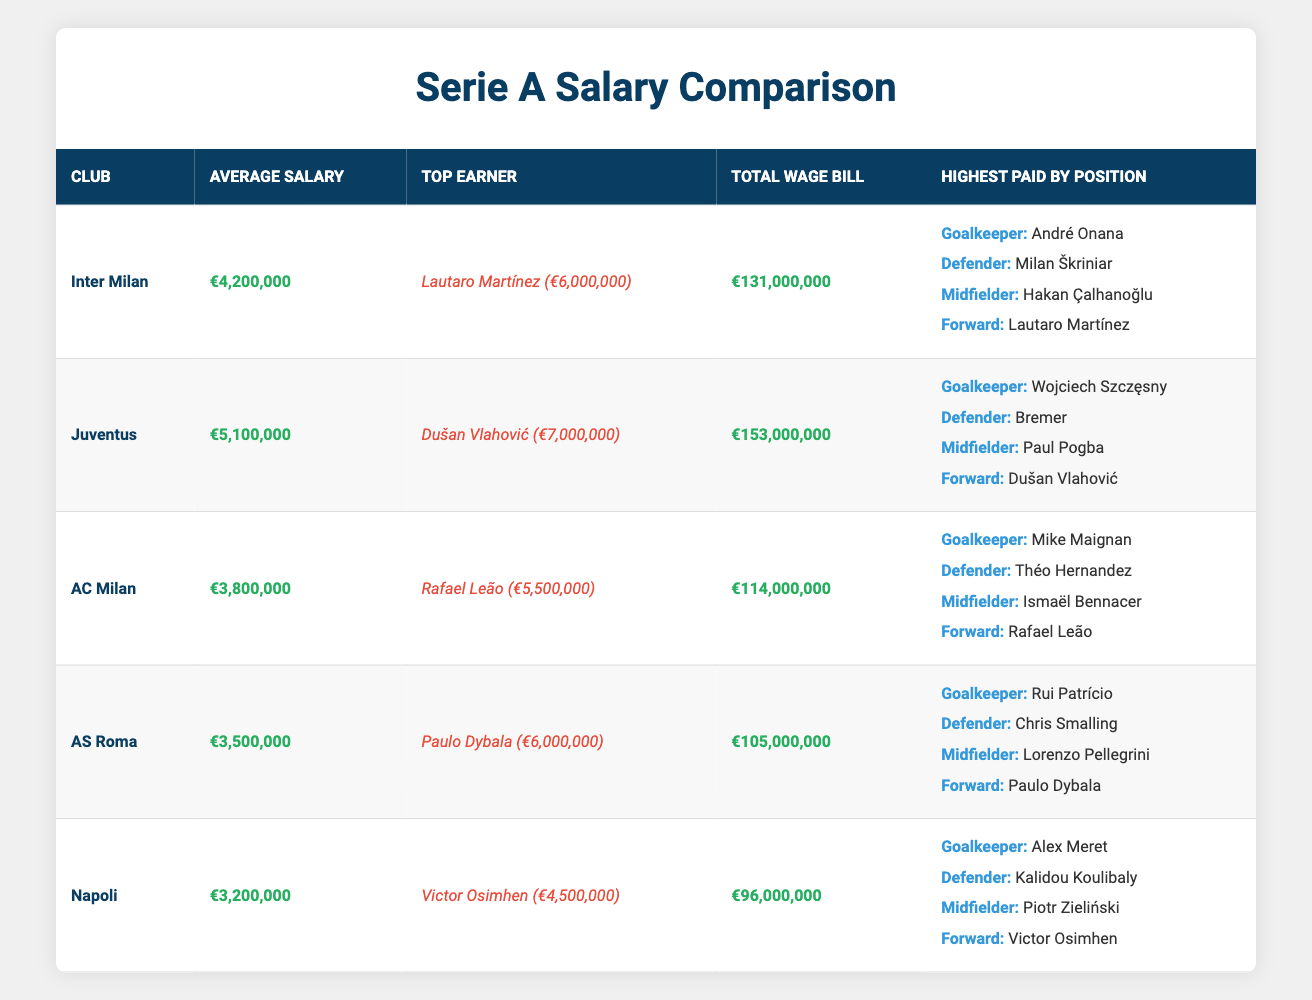What is the highest average salary among the Serie A clubs listed? Looking at the "Average Salary" column in the table, Juventus has an average salary of €5,100,000, which is higher than the average salaries of the other clubs listed.
Answer: €5,100,000 Which club has the top earner in Serie A? From the "Top Earner" column, Juventus has the top earner Dušan Vlahović with a salary of €7,000,000. This is the highest among all clubs listed in the table.
Answer: Juventus What is the total wage bill of Inter Milan? The "Total Wage Bill" for Inter Milan is listed as €131,000,000 in the table.
Answer: €131,000,000 Which position does Milan Škriniar play and how much is his salary? According to the "Highest Paid by Position" section for Inter Milan, Milan Škriniar plays as a Defender, but the salary is not listed in the table. However, he is the highest-paid Defender at Inter Milan.
Answer: Defender Is it true that AS Roma has a lower average salary than AC Milan? Yes, AS Roma has an average salary of €3,500,000, while AC Milan's average salary is €3,800,000. Thus, AS Roma’s average salary is indeed lower than that of AC Milan.
Answer: Yes What is the total wage bill difference between Inter Milan and Napoli? To find the difference, we subtract Napoli's total wage bill (€96,000,000) from Inter Milan's total wage bill (€131,000,000). The calculation is €131,000,000 - €96,000,000 = €35,000,000.
Answer: €35,000,000 Which club has the highest paid Forward? Lautaro Martínez from Inter Milan is the highest paid Forward, with a salary of €6,000,000. This can be seen under the "Highest Paid by Position" for Inter Milan.
Answer: Inter Milan Is Victor Osimhen the top earner for Napoli? Yes, Victor Osimhen is listed as the top earner for Napoli with a salary of €4,500,000 according to the table.
Answer: Yes What are the average salaries of the clubs in descending order? The average salaries in descending order are: Juventus (€5,100,000), Inter Milan (€4,200,000), AC Milan (€3,800,000), AS Roma (€3,500,000), Napoli (€3,200,000). This is gathered by checking the Average Salary column and sorting the values.
Answer: Juventus, Inter Milan, AC Milan, AS Roma, Napoli 